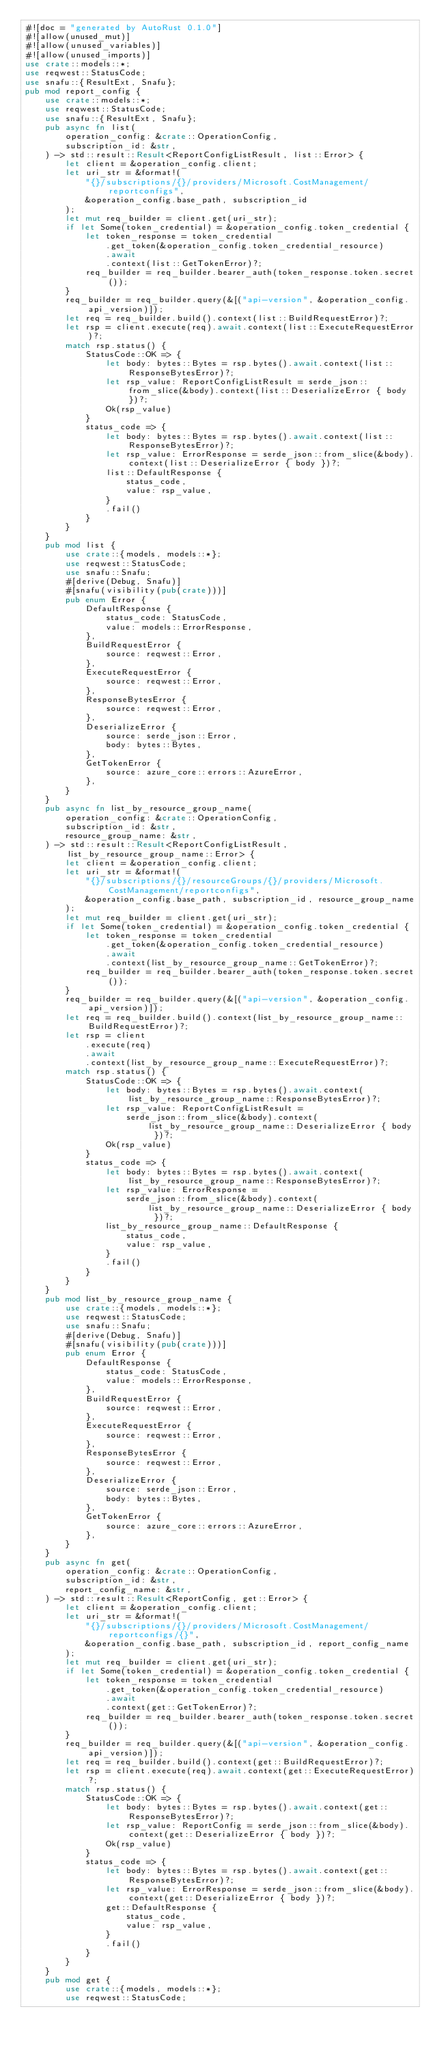Convert code to text. <code><loc_0><loc_0><loc_500><loc_500><_Rust_>#![doc = "generated by AutoRust 0.1.0"]
#![allow(unused_mut)]
#![allow(unused_variables)]
#![allow(unused_imports)]
use crate::models::*;
use reqwest::StatusCode;
use snafu::{ResultExt, Snafu};
pub mod report_config {
    use crate::models::*;
    use reqwest::StatusCode;
    use snafu::{ResultExt, Snafu};
    pub async fn list(
        operation_config: &crate::OperationConfig,
        subscription_id: &str,
    ) -> std::result::Result<ReportConfigListResult, list::Error> {
        let client = &operation_config.client;
        let uri_str = &format!(
            "{}/subscriptions/{}/providers/Microsoft.CostManagement/reportconfigs",
            &operation_config.base_path, subscription_id
        );
        let mut req_builder = client.get(uri_str);
        if let Some(token_credential) = &operation_config.token_credential {
            let token_response = token_credential
                .get_token(&operation_config.token_credential_resource)
                .await
                .context(list::GetTokenError)?;
            req_builder = req_builder.bearer_auth(token_response.token.secret());
        }
        req_builder = req_builder.query(&[("api-version", &operation_config.api_version)]);
        let req = req_builder.build().context(list::BuildRequestError)?;
        let rsp = client.execute(req).await.context(list::ExecuteRequestError)?;
        match rsp.status() {
            StatusCode::OK => {
                let body: bytes::Bytes = rsp.bytes().await.context(list::ResponseBytesError)?;
                let rsp_value: ReportConfigListResult = serde_json::from_slice(&body).context(list::DeserializeError { body })?;
                Ok(rsp_value)
            }
            status_code => {
                let body: bytes::Bytes = rsp.bytes().await.context(list::ResponseBytesError)?;
                let rsp_value: ErrorResponse = serde_json::from_slice(&body).context(list::DeserializeError { body })?;
                list::DefaultResponse {
                    status_code,
                    value: rsp_value,
                }
                .fail()
            }
        }
    }
    pub mod list {
        use crate::{models, models::*};
        use reqwest::StatusCode;
        use snafu::Snafu;
        #[derive(Debug, Snafu)]
        #[snafu(visibility(pub(crate)))]
        pub enum Error {
            DefaultResponse {
                status_code: StatusCode,
                value: models::ErrorResponse,
            },
            BuildRequestError {
                source: reqwest::Error,
            },
            ExecuteRequestError {
                source: reqwest::Error,
            },
            ResponseBytesError {
                source: reqwest::Error,
            },
            DeserializeError {
                source: serde_json::Error,
                body: bytes::Bytes,
            },
            GetTokenError {
                source: azure_core::errors::AzureError,
            },
        }
    }
    pub async fn list_by_resource_group_name(
        operation_config: &crate::OperationConfig,
        subscription_id: &str,
        resource_group_name: &str,
    ) -> std::result::Result<ReportConfigListResult, list_by_resource_group_name::Error> {
        let client = &operation_config.client;
        let uri_str = &format!(
            "{}/subscriptions/{}/resourceGroups/{}/providers/Microsoft.CostManagement/reportconfigs",
            &operation_config.base_path, subscription_id, resource_group_name
        );
        let mut req_builder = client.get(uri_str);
        if let Some(token_credential) = &operation_config.token_credential {
            let token_response = token_credential
                .get_token(&operation_config.token_credential_resource)
                .await
                .context(list_by_resource_group_name::GetTokenError)?;
            req_builder = req_builder.bearer_auth(token_response.token.secret());
        }
        req_builder = req_builder.query(&[("api-version", &operation_config.api_version)]);
        let req = req_builder.build().context(list_by_resource_group_name::BuildRequestError)?;
        let rsp = client
            .execute(req)
            .await
            .context(list_by_resource_group_name::ExecuteRequestError)?;
        match rsp.status() {
            StatusCode::OK => {
                let body: bytes::Bytes = rsp.bytes().await.context(list_by_resource_group_name::ResponseBytesError)?;
                let rsp_value: ReportConfigListResult =
                    serde_json::from_slice(&body).context(list_by_resource_group_name::DeserializeError { body })?;
                Ok(rsp_value)
            }
            status_code => {
                let body: bytes::Bytes = rsp.bytes().await.context(list_by_resource_group_name::ResponseBytesError)?;
                let rsp_value: ErrorResponse =
                    serde_json::from_slice(&body).context(list_by_resource_group_name::DeserializeError { body })?;
                list_by_resource_group_name::DefaultResponse {
                    status_code,
                    value: rsp_value,
                }
                .fail()
            }
        }
    }
    pub mod list_by_resource_group_name {
        use crate::{models, models::*};
        use reqwest::StatusCode;
        use snafu::Snafu;
        #[derive(Debug, Snafu)]
        #[snafu(visibility(pub(crate)))]
        pub enum Error {
            DefaultResponse {
                status_code: StatusCode,
                value: models::ErrorResponse,
            },
            BuildRequestError {
                source: reqwest::Error,
            },
            ExecuteRequestError {
                source: reqwest::Error,
            },
            ResponseBytesError {
                source: reqwest::Error,
            },
            DeserializeError {
                source: serde_json::Error,
                body: bytes::Bytes,
            },
            GetTokenError {
                source: azure_core::errors::AzureError,
            },
        }
    }
    pub async fn get(
        operation_config: &crate::OperationConfig,
        subscription_id: &str,
        report_config_name: &str,
    ) -> std::result::Result<ReportConfig, get::Error> {
        let client = &operation_config.client;
        let uri_str = &format!(
            "{}/subscriptions/{}/providers/Microsoft.CostManagement/reportconfigs/{}",
            &operation_config.base_path, subscription_id, report_config_name
        );
        let mut req_builder = client.get(uri_str);
        if let Some(token_credential) = &operation_config.token_credential {
            let token_response = token_credential
                .get_token(&operation_config.token_credential_resource)
                .await
                .context(get::GetTokenError)?;
            req_builder = req_builder.bearer_auth(token_response.token.secret());
        }
        req_builder = req_builder.query(&[("api-version", &operation_config.api_version)]);
        let req = req_builder.build().context(get::BuildRequestError)?;
        let rsp = client.execute(req).await.context(get::ExecuteRequestError)?;
        match rsp.status() {
            StatusCode::OK => {
                let body: bytes::Bytes = rsp.bytes().await.context(get::ResponseBytesError)?;
                let rsp_value: ReportConfig = serde_json::from_slice(&body).context(get::DeserializeError { body })?;
                Ok(rsp_value)
            }
            status_code => {
                let body: bytes::Bytes = rsp.bytes().await.context(get::ResponseBytesError)?;
                let rsp_value: ErrorResponse = serde_json::from_slice(&body).context(get::DeserializeError { body })?;
                get::DefaultResponse {
                    status_code,
                    value: rsp_value,
                }
                .fail()
            }
        }
    }
    pub mod get {
        use crate::{models, models::*};
        use reqwest::StatusCode;</code> 